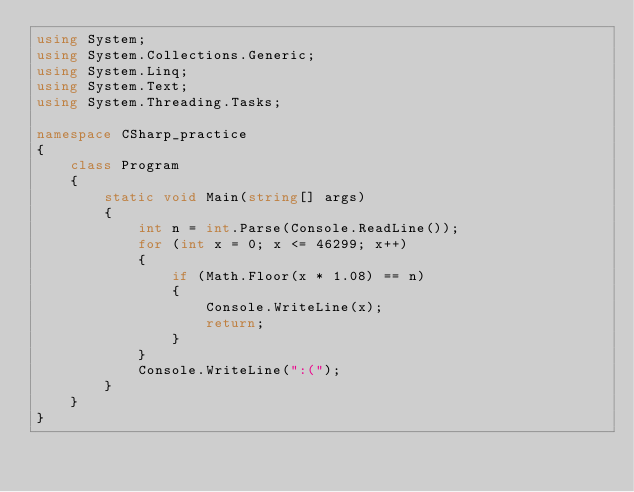Convert code to text. <code><loc_0><loc_0><loc_500><loc_500><_C#_>using System;
using System.Collections.Generic;
using System.Linq;
using System.Text;
using System.Threading.Tasks;

namespace CSharp_practice
{
    class Program
    {
        static void Main(string[] args)
        {
            int n = int.Parse(Console.ReadLine());
            for (int x = 0; x <= 46299; x++)
            {
                if (Math.Floor(x * 1.08) == n)
                {
                    Console.WriteLine(x);
                    return;
                }
            }
            Console.WriteLine(":(");
        }
    }
}
</code> 